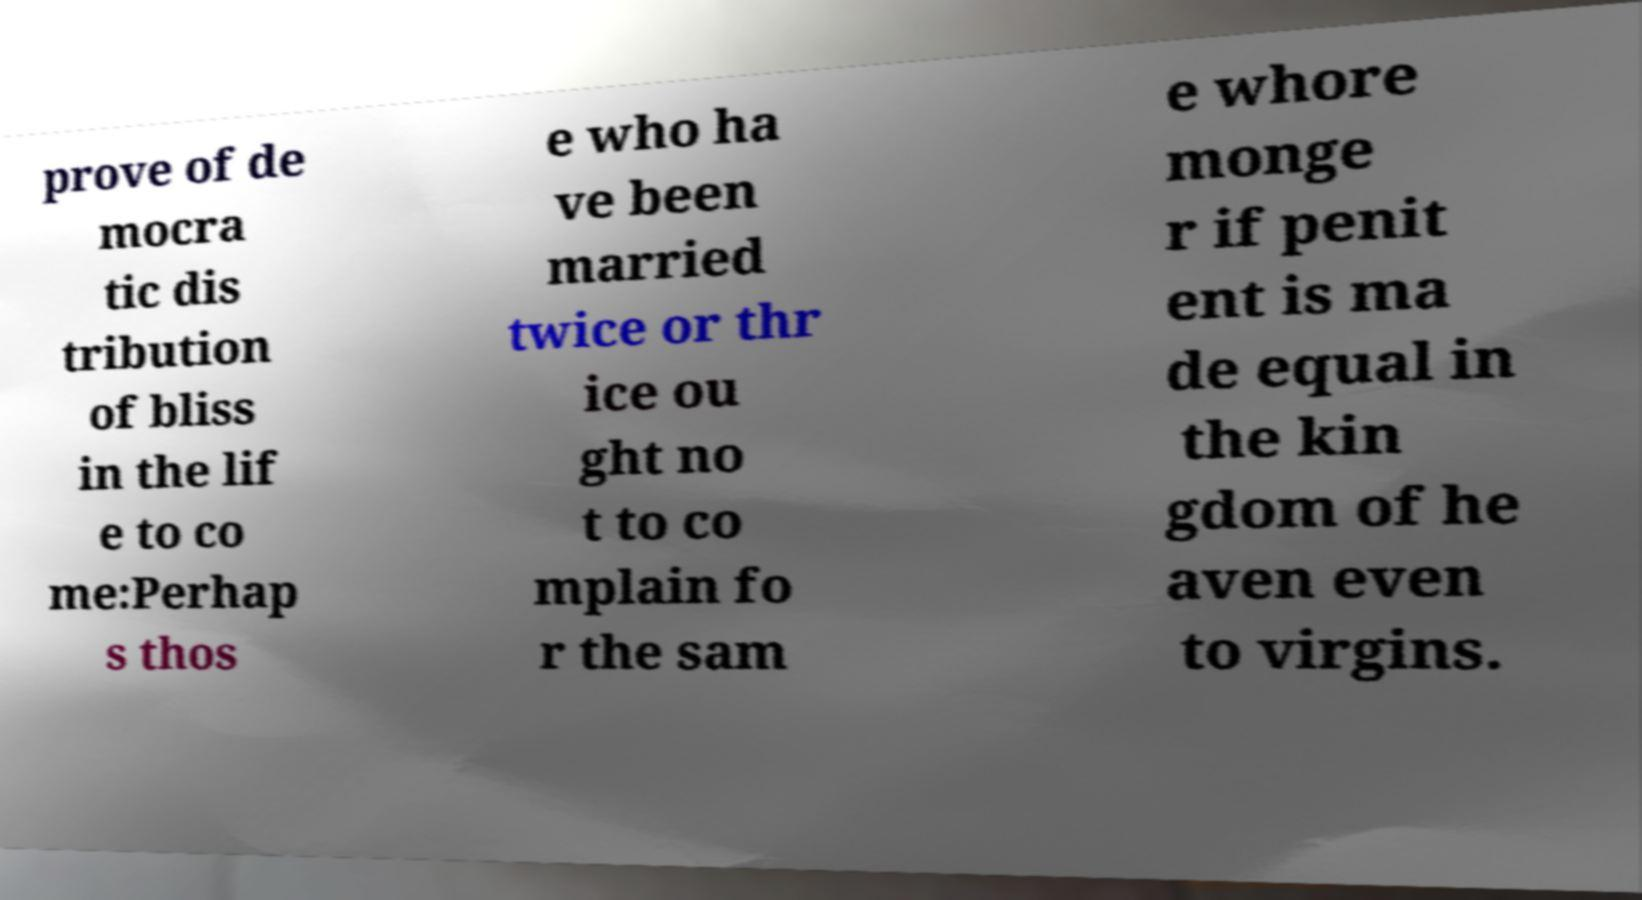Can you read and provide the text displayed in the image?This photo seems to have some interesting text. Can you extract and type it out for me? prove of de mocra tic dis tribution of bliss in the lif e to co me:Perhap s thos e who ha ve been married twice or thr ice ou ght no t to co mplain fo r the sam e whore monge r if penit ent is ma de equal in the kin gdom of he aven even to virgins. 